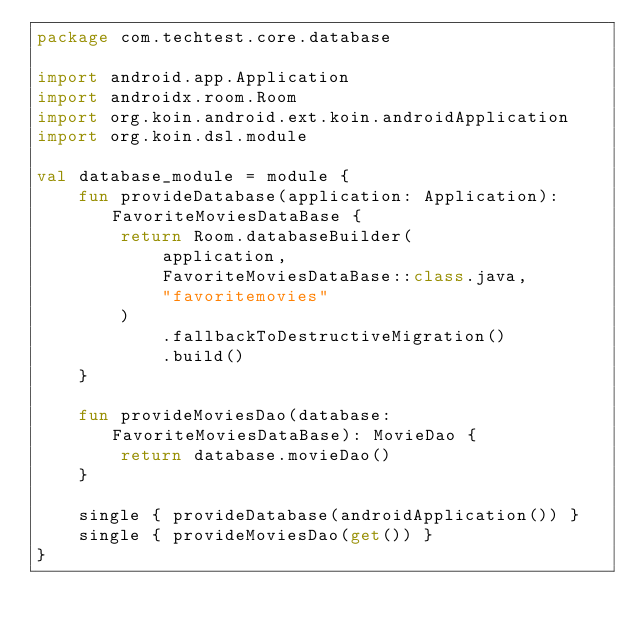Convert code to text. <code><loc_0><loc_0><loc_500><loc_500><_Kotlin_>package com.techtest.core.database

import android.app.Application
import androidx.room.Room
import org.koin.android.ext.koin.androidApplication
import org.koin.dsl.module

val database_module = module {
    fun provideDatabase(application: Application): FavoriteMoviesDataBase {
        return Room.databaseBuilder(
            application,
            FavoriteMoviesDataBase::class.java,
            "favoritemovies"
        )
            .fallbackToDestructiveMigration()
            .build()
    }

    fun provideMoviesDao(database: FavoriteMoviesDataBase): MovieDao {
        return database.movieDao()
    }

    single { provideDatabase(androidApplication()) }
    single { provideMoviesDao(get()) }
}
</code> 